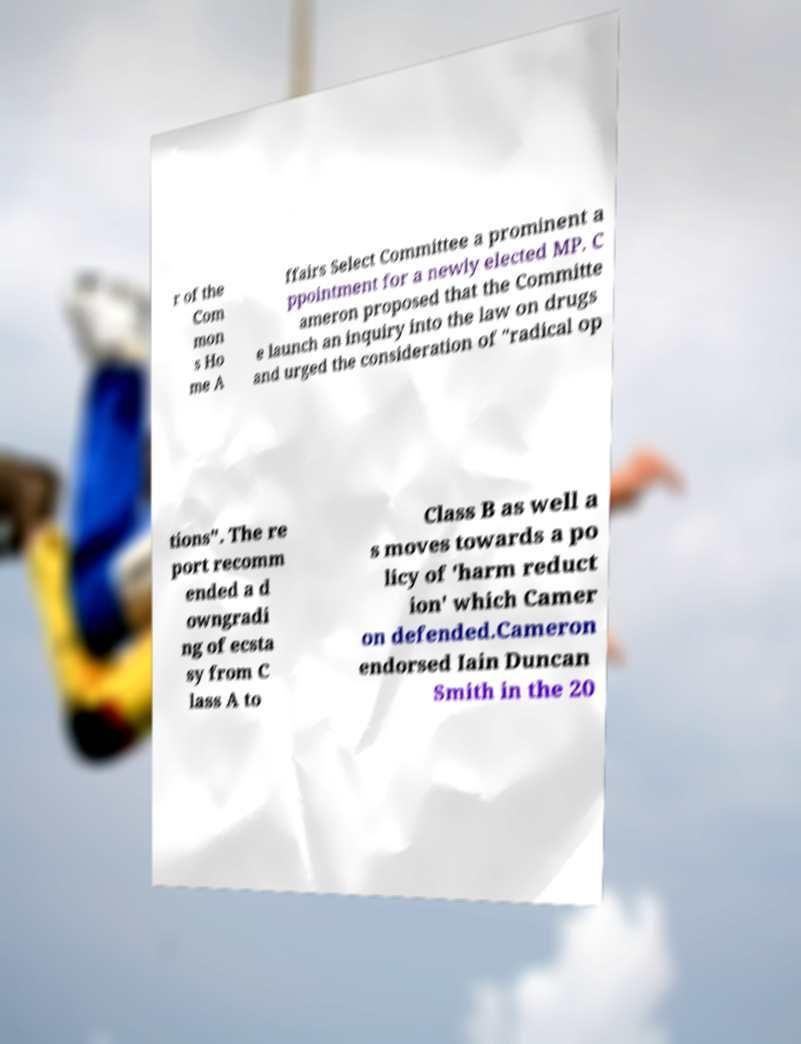What messages or text are displayed in this image? I need them in a readable, typed format. r of the Com mon s Ho me A ffairs Select Committee a prominent a ppointment for a newly elected MP. C ameron proposed that the Committe e launch an inquiry into the law on drugs and urged the consideration of "radical op tions". The re port recomm ended a d owngradi ng of ecsta sy from C lass A to Class B as well a s moves towards a po licy of 'harm reduct ion' which Camer on defended.Cameron endorsed Iain Duncan Smith in the 20 